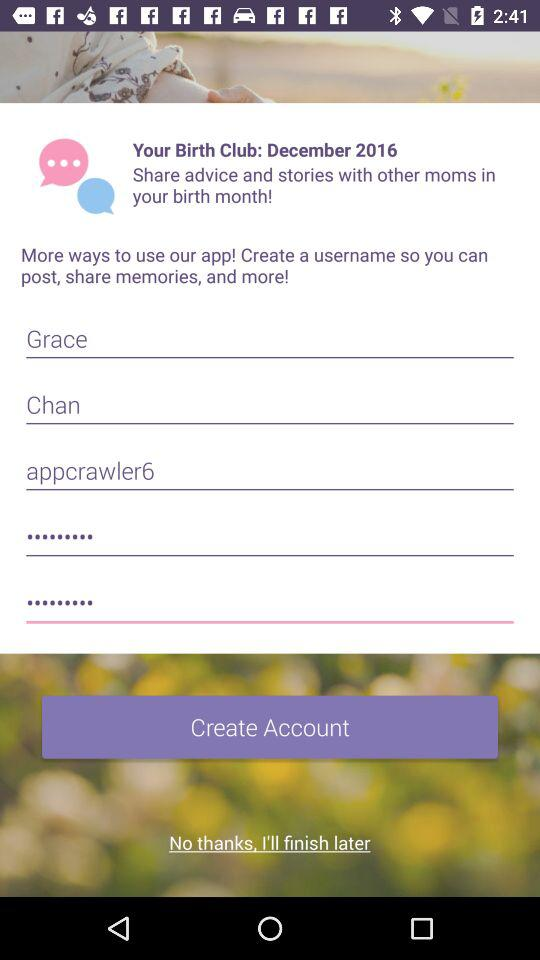What is the Email Address?
When the provided information is insufficient, respond with <no answer>. <no answer> 